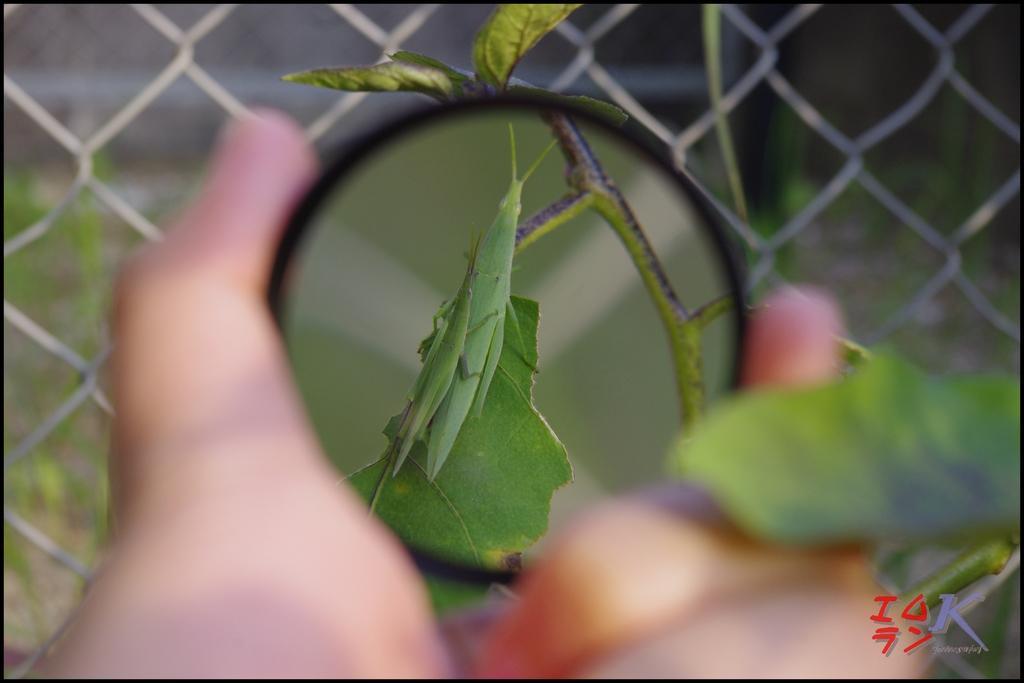Could you give a brief overview of what you see in this image? In the picture we can see some person's hand who is holding magnifying glass through which we can see leaf and in the background of the picture there is iron fencing. 